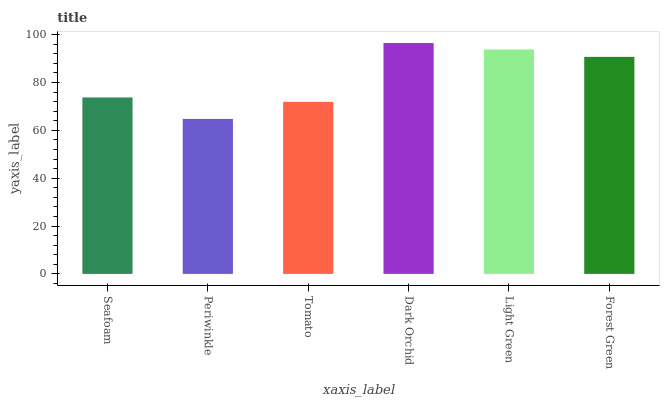Is Tomato the minimum?
Answer yes or no. No. Is Tomato the maximum?
Answer yes or no. No. Is Tomato greater than Periwinkle?
Answer yes or no. Yes. Is Periwinkle less than Tomato?
Answer yes or no. Yes. Is Periwinkle greater than Tomato?
Answer yes or no. No. Is Tomato less than Periwinkle?
Answer yes or no. No. Is Forest Green the high median?
Answer yes or no. Yes. Is Seafoam the low median?
Answer yes or no. Yes. Is Periwinkle the high median?
Answer yes or no. No. Is Tomato the low median?
Answer yes or no. No. 